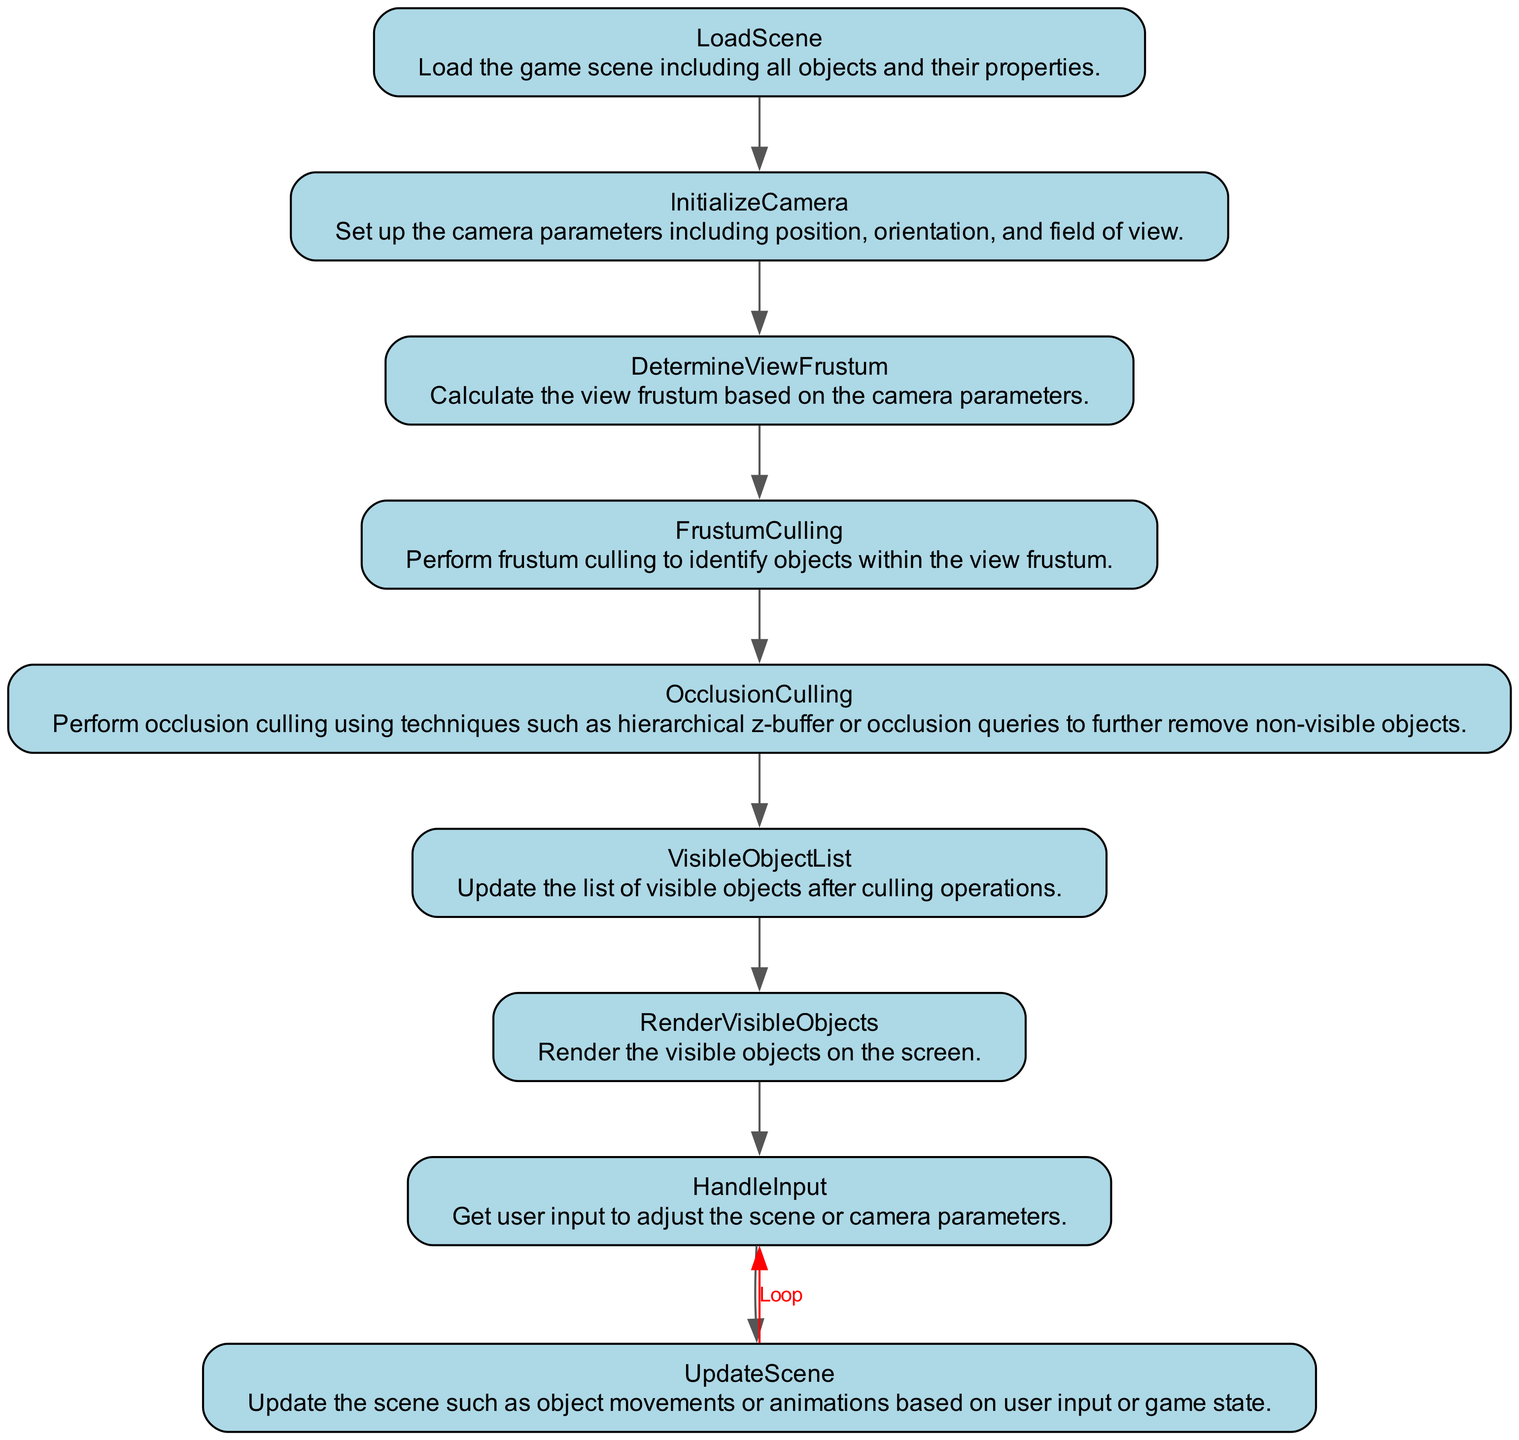What is the first step in the flowchart? The first step is "LoadScene," which initializes the loading of game objects in the scene.
Answer: LoadScene How many nodes are in the flowchart? There are a total of eight nodes representing different steps in the process described by the flowchart.
Answer: Eight Which node comes after "DetermineViewFrustum"? "FrustumCulling" follows "DetermineViewFrustum" as the next step in the rendering process.
Answer: FrustumCulling What is the last step before the loop back to "HandleInput"? The last step before looping back to "HandleInput" is "RenderVisibleObjects," where the visible objects are rendered on the screen for the user.
Answer: RenderVisibleObjects What type of culling is performed after frustum culling? "OcclusionCulling" is performed after frustum culling to eliminate non-visible objects further.
Answer: OcclusionCulling Which node updates the list of visible objects? The "VisibleObjectList" node is responsible for updating the list that contains the current visible objects after applying culling techniques.
Answer: VisibleObjectList How does the flowchart indicate the process loops? The flowchart uses a red edge labeled "Loop" from the last node ("RenderVisibleObjects") back to "HandleInput" to show the iterative nature of the process.
Answer: Loop Which node uses a calculation based on camera parameters? "DetermineViewFrustum" uses calculations derived from the camera parameters to establish the view frustum.
Answer: DetermineViewFrustum What does the "HandleInput" node represent? The "HandleInput" node represents the stage where user input is gathered to modify the scene or camera settings.
Answer: User input 